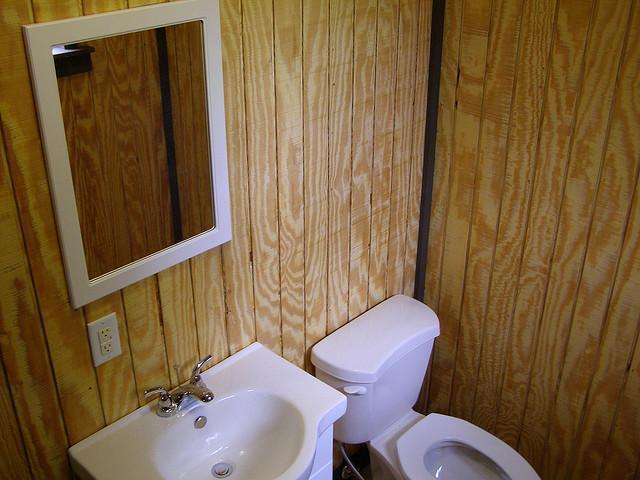How many people are there in the picture?
Give a very brief answer. 0. 